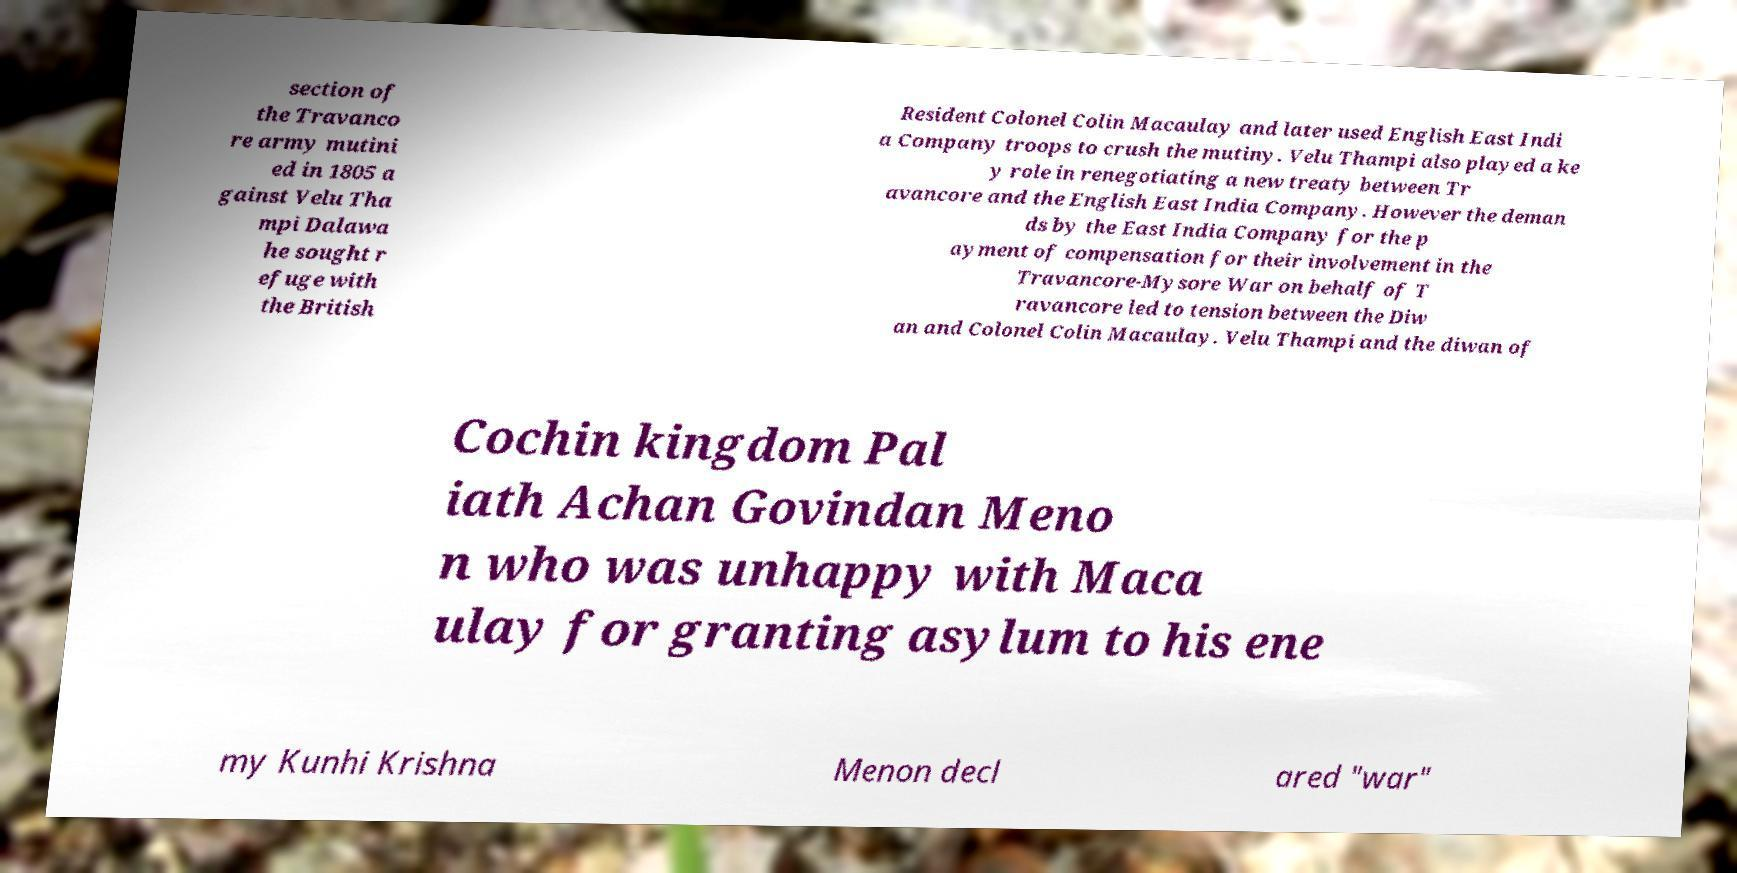Can you accurately transcribe the text from the provided image for me? section of the Travanco re army mutini ed in 1805 a gainst Velu Tha mpi Dalawa he sought r efuge with the British Resident Colonel Colin Macaulay and later used English East Indi a Company troops to crush the mutiny. Velu Thampi also played a ke y role in renegotiating a new treaty between Tr avancore and the English East India Company. However the deman ds by the East India Company for the p ayment of compensation for their involvement in the Travancore-Mysore War on behalf of T ravancore led to tension between the Diw an and Colonel Colin Macaulay. Velu Thampi and the diwan of Cochin kingdom Pal iath Achan Govindan Meno n who was unhappy with Maca ulay for granting asylum to his ene my Kunhi Krishna Menon decl ared "war" 